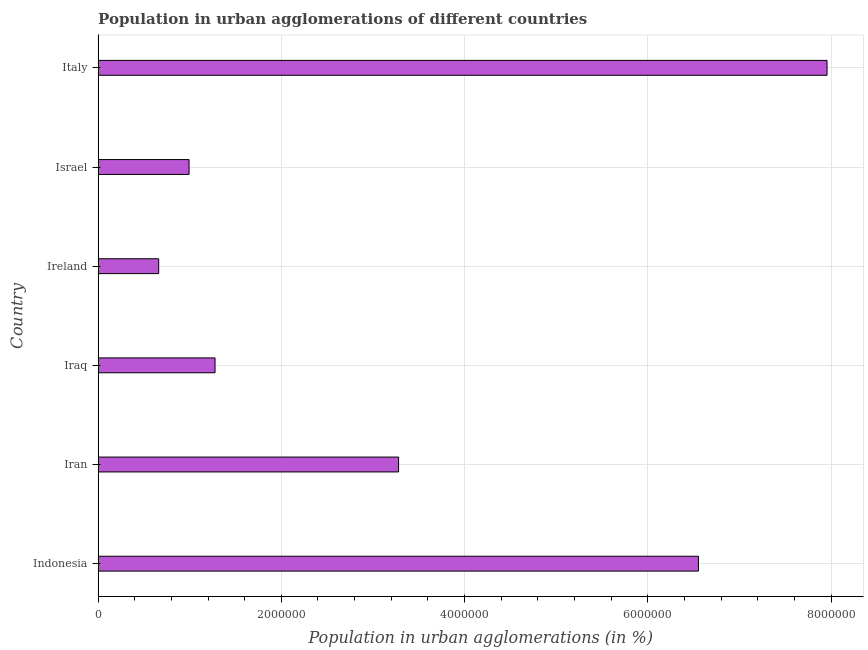What is the title of the graph?
Give a very brief answer. Population in urban agglomerations of different countries. What is the label or title of the X-axis?
Ensure brevity in your answer.  Population in urban agglomerations (in %). What is the population in urban agglomerations in Ireland?
Provide a short and direct response. 6.61e+05. Across all countries, what is the maximum population in urban agglomerations?
Offer a terse response. 7.96e+06. Across all countries, what is the minimum population in urban agglomerations?
Make the answer very short. 6.61e+05. In which country was the population in urban agglomerations minimum?
Offer a terse response. Ireland. What is the sum of the population in urban agglomerations?
Provide a succinct answer. 2.07e+07. What is the difference between the population in urban agglomerations in Iran and Ireland?
Offer a terse response. 2.62e+06. What is the average population in urban agglomerations per country?
Make the answer very short. 3.45e+06. What is the median population in urban agglomerations?
Give a very brief answer. 2.28e+06. What is the ratio of the population in urban agglomerations in Indonesia to that in Israel?
Keep it short and to the point. 6.6. Is the difference between the population in urban agglomerations in Iraq and Ireland greater than the difference between any two countries?
Your response must be concise. No. What is the difference between the highest and the second highest population in urban agglomerations?
Keep it short and to the point. 1.40e+06. What is the difference between the highest and the lowest population in urban agglomerations?
Provide a short and direct response. 7.30e+06. How many bars are there?
Offer a very short reply. 6. How many countries are there in the graph?
Your answer should be compact. 6. What is the Population in urban agglomerations (in %) of Indonesia?
Make the answer very short. 6.55e+06. What is the Population in urban agglomerations (in %) in Iran?
Ensure brevity in your answer.  3.28e+06. What is the Population in urban agglomerations (in %) in Iraq?
Ensure brevity in your answer.  1.28e+06. What is the Population in urban agglomerations (in %) of Ireland?
Offer a terse response. 6.61e+05. What is the Population in urban agglomerations (in %) in Israel?
Your answer should be compact. 9.93e+05. What is the Population in urban agglomerations (in %) of Italy?
Provide a succinct answer. 7.96e+06. What is the difference between the Population in urban agglomerations (in %) in Indonesia and Iran?
Make the answer very short. 3.27e+06. What is the difference between the Population in urban agglomerations (in %) in Indonesia and Iraq?
Your answer should be very brief. 5.28e+06. What is the difference between the Population in urban agglomerations (in %) in Indonesia and Ireland?
Keep it short and to the point. 5.89e+06. What is the difference between the Population in urban agglomerations (in %) in Indonesia and Israel?
Your answer should be compact. 5.56e+06. What is the difference between the Population in urban agglomerations (in %) in Indonesia and Italy?
Provide a short and direct response. -1.40e+06. What is the difference between the Population in urban agglomerations (in %) in Iran and Iraq?
Offer a very short reply. 2.00e+06. What is the difference between the Population in urban agglomerations (in %) in Iran and Ireland?
Ensure brevity in your answer.  2.62e+06. What is the difference between the Population in urban agglomerations (in %) in Iran and Israel?
Make the answer very short. 2.29e+06. What is the difference between the Population in urban agglomerations (in %) in Iran and Italy?
Offer a terse response. -4.68e+06. What is the difference between the Population in urban agglomerations (in %) in Iraq and Ireland?
Keep it short and to the point. 6.15e+05. What is the difference between the Population in urban agglomerations (in %) in Iraq and Israel?
Make the answer very short. 2.84e+05. What is the difference between the Population in urban agglomerations (in %) in Iraq and Italy?
Ensure brevity in your answer.  -6.68e+06. What is the difference between the Population in urban agglomerations (in %) in Ireland and Israel?
Provide a succinct answer. -3.32e+05. What is the difference between the Population in urban agglomerations (in %) in Ireland and Italy?
Your response must be concise. -7.30e+06. What is the difference between the Population in urban agglomerations (in %) in Israel and Italy?
Give a very brief answer. -6.96e+06. What is the ratio of the Population in urban agglomerations (in %) in Indonesia to that in Iran?
Make the answer very short. 2. What is the ratio of the Population in urban agglomerations (in %) in Indonesia to that in Iraq?
Give a very brief answer. 5.13. What is the ratio of the Population in urban agglomerations (in %) in Indonesia to that in Ireland?
Ensure brevity in your answer.  9.91. What is the ratio of the Population in urban agglomerations (in %) in Indonesia to that in Israel?
Your response must be concise. 6.6. What is the ratio of the Population in urban agglomerations (in %) in Indonesia to that in Italy?
Give a very brief answer. 0.82. What is the ratio of the Population in urban agglomerations (in %) in Iran to that in Iraq?
Ensure brevity in your answer.  2.57. What is the ratio of the Population in urban agglomerations (in %) in Iran to that in Ireland?
Offer a very short reply. 4.96. What is the ratio of the Population in urban agglomerations (in %) in Iran to that in Israel?
Keep it short and to the point. 3.3. What is the ratio of the Population in urban agglomerations (in %) in Iran to that in Italy?
Keep it short and to the point. 0.41. What is the ratio of the Population in urban agglomerations (in %) in Iraq to that in Ireland?
Keep it short and to the point. 1.93. What is the ratio of the Population in urban agglomerations (in %) in Iraq to that in Israel?
Offer a terse response. 1.29. What is the ratio of the Population in urban agglomerations (in %) in Iraq to that in Italy?
Provide a succinct answer. 0.16. What is the ratio of the Population in urban agglomerations (in %) in Ireland to that in Israel?
Your response must be concise. 0.67. What is the ratio of the Population in urban agglomerations (in %) in Ireland to that in Italy?
Offer a terse response. 0.08. 